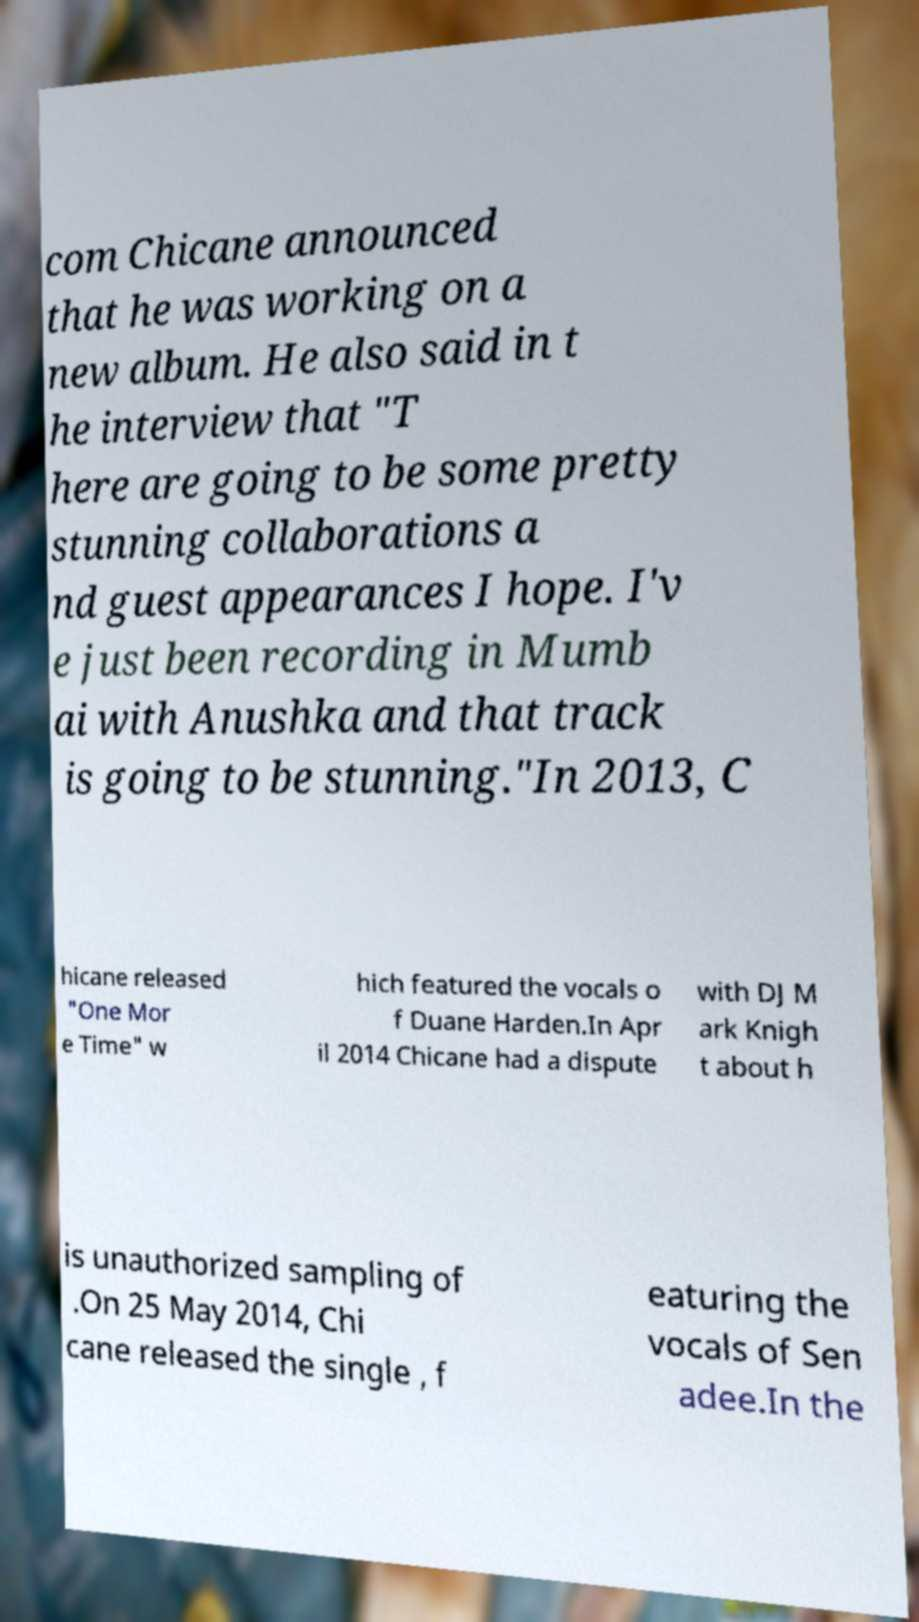There's text embedded in this image that I need extracted. Can you transcribe it verbatim? com Chicane announced that he was working on a new album. He also said in t he interview that "T here are going to be some pretty stunning collaborations a nd guest appearances I hope. I'v e just been recording in Mumb ai with Anushka and that track is going to be stunning."In 2013, C hicane released "One Mor e Time" w hich featured the vocals o f Duane Harden.In Apr il 2014 Chicane had a dispute with DJ M ark Knigh t about h is unauthorized sampling of .On 25 May 2014, Chi cane released the single , f eaturing the vocals of Sen adee.In the 